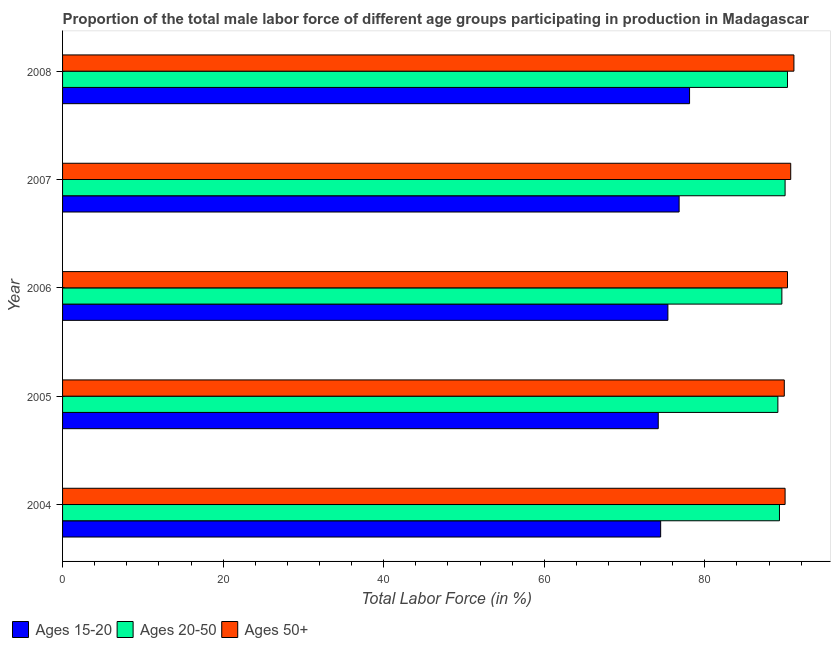How many different coloured bars are there?
Offer a terse response. 3. Are the number of bars on each tick of the Y-axis equal?
Give a very brief answer. Yes. How many bars are there on the 5th tick from the top?
Your answer should be very brief. 3. How many bars are there on the 3rd tick from the bottom?
Provide a short and direct response. 3. In how many cases, is the number of bars for a given year not equal to the number of legend labels?
Give a very brief answer. 0. What is the percentage of male labor force within the age group 20-50 in 2005?
Ensure brevity in your answer.  89.1. Across all years, what is the maximum percentage of male labor force within the age group 20-50?
Your response must be concise. 90.3. Across all years, what is the minimum percentage of male labor force within the age group 20-50?
Offer a terse response. 89.1. In which year was the percentage of male labor force within the age group 20-50 minimum?
Provide a succinct answer. 2005. What is the total percentage of male labor force above age 50 in the graph?
Make the answer very short. 452. What is the difference between the percentage of male labor force within the age group 15-20 in 2004 and that in 2007?
Give a very brief answer. -2.3. What is the difference between the percentage of male labor force within the age group 15-20 in 2006 and the percentage of male labor force within the age group 20-50 in 2008?
Keep it short and to the point. -14.9. What is the average percentage of male labor force within the age group 15-20 per year?
Offer a very short reply. 75.8. In how many years, is the percentage of male labor force above age 50 greater than 84 %?
Offer a terse response. 5. Is the difference between the percentage of male labor force above age 50 in 2004 and 2008 greater than the difference between the percentage of male labor force within the age group 15-20 in 2004 and 2008?
Offer a terse response. Yes. In how many years, is the percentage of male labor force within the age group 20-50 greater than the average percentage of male labor force within the age group 20-50 taken over all years?
Make the answer very short. 2. What does the 1st bar from the top in 2007 represents?
Your answer should be compact. Ages 50+. What does the 2nd bar from the bottom in 2007 represents?
Your answer should be compact. Ages 20-50. Are all the bars in the graph horizontal?
Offer a very short reply. Yes. How many years are there in the graph?
Provide a succinct answer. 5. Are the values on the major ticks of X-axis written in scientific E-notation?
Your response must be concise. No. Does the graph contain any zero values?
Provide a short and direct response. No. How are the legend labels stacked?
Offer a very short reply. Horizontal. What is the title of the graph?
Provide a succinct answer. Proportion of the total male labor force of different age groups participating in production in Madagascar. What is the label or title of the X-axis?
Keep it short and to the point. Total Labor Force (in %). What is the label or title of the Y-axis?
Keep it short and to the point. Year. What is the Total Labor Force (in %) in Ages 15-20 in 2004?
Your answer should be very brief. 74.5. What is the Total Labor Force (in %) in Ages 20-50 in 2004?
Provide a succinct answer. 89.3. What is the Total Labor Force (in %) of Ages 15-20 in 2005?
Make the answer very short. 74.2. What is the Total Labor Force (in %) of Ages 20-50 in 2005?
Provide a succinct answer. 89.1. What is the Total Labor Force (in %) in Ages 50+ in 2005?
Ensure brevity in your answer.  89.9. What is the Total Labor Force (in %) in Ages 15-20 in 2006?
Offer a terse response. 75.4. What is the Total Labor Force (in %) of Ages 20-50 in 2006?
Provide a short and direct response. 89.6. What is the Total Labor Force (in %) of Ages 50+ in 2006?
Your answer should be very brief. 90.3. What is the Total Labor Force (in %) of Ages 15-20 in 2007?
Give a very brief answer. 76.8. What is the Total Labor Force (in %) of Ages 50+ in 2007?
Give a very brief answer. 90.7. What is the Total Labor Force (in %) in Ages 15-20 in 2008?
Make the answer very short. 78.1. What is the Total Labor Force (in %) of Ages 20-50 in 2008?
Your response must be concise. 90.3. What is the Total Labor Force (in %) in Ages 50+ in 2008?
Ensure brevity in your answer.  91.1. Across all years, what is the maximum Total Labor Force (in %) of Ages 15-20?
Your answer should be compact. 78.1. Across all years, what is the maximum Total Labor Force (in %) of Ages 20-50?
Ensure brevity in your answer.  90.3. Across all years, what is the maximum Total Labor Force (in %) in Ages 50+?
Keep it short and to the point. 91.1. Across all years, what is the minimum Total Labor Force (in %) of Ages 15-20?
Ensure brevity in your answer.  74.2. Across all years, what is the minimum Total Labor Force (in %) of Ages 20-50?
Give a very brief answer. 89.1. Across all years, what is the minimum Total Labor Force (in %) in Ages 50+?
Offer a very short reply. 89.9. What is the total Total Labor Force (in %) of Ages 15-20 in the graph?
Offer a very short reply. 379. What is the total Total Labor Force (in %) in Ages 20-50 in the graph?
Provide a short and direct response. 448.3. What is the total Total Labor Force (in %) of Ages 50+ in the graph?
Your answer should be very brief. 452. What is the difference between the Total Labor Force (in %) of Ages 15-20 in 2004 and that in 2005?
Ensure brevity in your answer.  0.3. What is the difference between the Total Labor Force (in %) of Ages 50+ in 2004 and that in 2005?
Your response must be concise. 0.1. What is the difference between the Total Labor Force (in %) of Ages 20-50 in 2004 and that in 2006?
Your answer should be very brief. -0.3. What is the difference between the Total Labor Force (in %) of Ages 50+ in 2004 and that in 2006?
Your answer should be very brief. -0.3. What is the difference between the Total Labor Force (in %) of Ages 15-20 in 2004 and that in 2007?
Your answer should be very brief. -2.3. What is the difference between the Total Labor Force (in %) of Ages 20-50 in 2004 and that in 2007?
Make the answer very short. -0.7. What is the difference between the Total Labor Force (in %) in Ages 50+ in 2004 and that in 2007?
Your answer should be compact. -0.7. What is the difference between the Total Labor Force (in %) in Ages 15-20 in 2004 and that in 2008?
Provide a succinct answer. -3.6. What is the difference between the Total Labor Force (in %) in Ages 50+ in 2004 and that in 2008?
Offer a very short reply. -1.1. What is the difference between the Total Labor Force (in %) in Ages 20-50 in 2005 and that in 2006?
Make the answer very short. -0.5. What is the difference between the Total Labor Force (in %) of Ages 15-20 in 2005 and that in 2007?
Keep it short and to the point. -2.6. What is the difference between the Total Labor Force (in %) of Ages 50+ in 2005 and that in 2007?
Offer a very short reply. -0.8. What is the difference between the Total Labor Force (in %) of Ages 15-20 in 2006 and that in 2008?
Make the answer very short. -2.7. What is the difference between the Total Labor Force (in %) of Ages 20-50 in 2006 and that in 2008?
Your answer should be very brief. -0.7. What is the difference between the Total Labor Force (in %) of Ages 50+ in 2006 and that in 2008?
Your answer should be compact. -0.8. What is the difference between the Total Labor Force (in %) in Ages 20-50 in 2007 and that in 2008?
Keep it short and to the point. -0.3. What is the difference between the Total Labor Force (in %) of Ages 15-20 in 2004 and the Total Labor Force (in %) of Ages 20-50 in 2005?
Offer a terse response. -14.6. What is the difference between the Total Labor Force (in %) in Ages 15-20 in 2004 and the Total Labor Force (in %) in Ages 50+ in 2005?
Provide a short and direct response. -15.4. What is the difference between the Total Labor Force (in %) of Ages 20-50 in 2004 and the Total Labor Force (in %) of Ages 50+ in 2005?
Keep it short and to the point. -0.6. What is the difference between the Total Labor Force (in %) of Ages 15-20 in 2004 and the Total Labor Force (in %) of Ages 20-50 in 2006?
Your answer should be compact. -15.1. What is the difference between the Total Labor Force (in %) of Ages 15-20 in 2004 and the Total Labor Force (in %) of Ages 50+ in 2006?
Offer a terse response. -15.8. What is the difference between the Total Labor Force (in %) of Ages 15-20 in 2004 and the Total Labor Force (in %) of Ages 20-50 in 2007?
Your answer should be compact. -15.5. What is the difference between the Total Labor Force (in %) of Ages 15-20 in 2004 and the Total Labor Force (in %) of Ages 50+ in 2007?
Your answer should be compact. -16.2. What is the difference between the Total Labor Force (in %) of Ages 20-50 in 2004 and the Total Labor Force (in %) of Ages 50+ in 2007?
Provide a short and direct response. -1.4. What is the difference between the Total Labor Force (in %) in Ages 15-20 in 2004 and the Total Labor Force (in %) in Ages 20-50 in 2008?
Your answer should be compact. -15.8. What is the difference between the Total Labor Force (in %) of Ages 15-20 in 2004 and the Total Labor Force (in %) of Ages 50+ in 2008?
Ensure brevity in your answer.  -16.6. What is the difference between the Total Labor Force (in %) of Ages 15-20 in 2005 and the Total Labor Force (in %) of Ages 20-50 in 2006?
Your answer should be compact. -15.4. What is the difference between the Total Labor Force (in %) in Ages 15-20 in 2005 and the Total Labor Force (in %) in Ages 50+ in 2006?
Make the answer very short. -16.1. What is the difference between the Total Labor Force (in %) in Ages 20-50 in 2005 and the Total Labor Force (in %) in Ages 50+ in 2006?
Your answer should be compact. -1.2. What is the difference between the Total Labor Force (in %) of Ages 15-20 in 2005 and the Total Labor Force (in %) of Ages 20-50 in 2007?
Give a very brief answer. -15.8. What is the difference between the Total Labor Force (in %) of Ages 15-20 in 2005 and the Total Labor Force (in %) of Ages 50+ in 2007?
Provide a succinct answer. -16.5. What is the difference between the Total Labor Force (in %) in Ages 20-50 in 2005 and the Total Labor Force (in %) in Ages 50+ in 2007?
Keep it short and to the point. -1.6. What is the difference between the Total Labor Force (in %) in Ages 15-20 in 2005 and the Total Labor Force (in %) in Ages 20-50 in 2008?
Your answer should be compact. -16.1. What is the difference between the Total Labor Force (in %) in Ages 15-20 in 2005 and the Total Labor Force (in %) in Ages 50+ in 2008?
Offer a terse response. -16.9. What is the difference between the Total Labor Force (in %) in Ages 20-50 in 2005 and the Total Labor Force (in %) in Ages 50+ in 2008?
Provide a succinct answer. -2. What is the difference between the Total Labor Force (in %) of Ages 15-20 in 2006 and the Total Labor Force (in %) of Ages 20-50 in 2007?
Make the answer very short. -14.6. What is the difference between the Total Labor Force (in %) in Ages 15-20 in 2006 and the Total Labor Force (in %) in Ages 50+ in 2007?
Provide a short and direct response. -15.3. What is the difference between the Total Labor Force (in %) in Ages 20-50 in 2006 and the Total Labor Force (in %) in Ages 50+ in 2007?
Offer a terse response. -1.1. What is the difference between the Total Labor Force (in %) in Ages 15-20 in 2006 and the Total Labor Force (in %) in Ages 20-50 in 2008?
Ensure brevity in your answer.  -14.9. What is the difference between the Total Labor Force (in %) in Ages 15-20 in 2006 and the Total Labor Force (in %) in Ages 50+ in 2008?
Your response must be concise. -15.7. What is the difference between the Total Labor Force (in %) in Ages 15-20 in 2007 and the Total Labor Force (in %) in Ages 20-50 in 2008?
Your response must be concise. -13.5. What is the difference between the Total Labor Force (in %) of Ages 15-20 in 2007 and the Total Labor Force (in %) of Ages 50+ in 2008?
Provide a succinct answer. -14.3. What is the average Total Labor Force (in %) of Ages 15-20 per year?
Provide a short and direct response. 75.8. What is the average Total Labor Force (in %) in Ages 20-50 per year?
Provide a short and direct response. 89.66. What is the average Total Labor Force (in %) in Ages 50+ per year?
Give a very brief answer. 90.4. In the year 2004, what is the difference between the Total Labor Force (in %) in Ages 15-20 and Total Labor Force (in %) in Ages 20-50?
Make the answer very short. -14.8. In the year 2004, what is the difference between the Total Labor Force (in %) of Ages 15-20 and Total Labor Force (in %) of Ages 50+?
Keep it short and to the point. -15.5. In the year 2005, what is the difference between the Total Labor Force (in %) of Ages 15-20 and Total Labor Force (in %) of Ages 20-50?
Your answer should be very brief. -14.9. In the year 2005, what is the difference between the Total Labor Force (in %) of Ages 15-20 and Total Labor Force (in %) of Ages 50+?
Provide a short and direct response. -15.7. In the year 2006, what is the difference between the Total Labor Force (in %) of Ages 15-20 and Total Labor Force (in %) of Ages 50+?
Offer a very short reply. -14.9. In the year 2008, what is the difference between the Total Labor Force (in %) of Ages 15-20 and Total Labor Force (in %) of Ages 20-50?
Keep it short and to the point. -12.2. What is the ratio of the Total Labor Force (in %) in Ages 50+ in 2004 to that in 2005?
Your answer should be very brief. 1. What is the ratio of the Total Labor Force (in %) in Ages 15-20 in 2004 to that in 2007?
Give a very brief answer. 0.97. What is the ratio of the Total Labor Force (in %) in Ages 20-50 in 2004 to that in 2007?
Your answer should be very brief. 0.99. What is the ratio of the Total Labor Force (in %) in Ages 15-20 in 2004 to that in 2008?
Give a very brief answer. 0.95. What is the ratio of the Total Labor Force (in %) in Ages 20-50 in 2004 to that in 2008?
Ensure brevity in your answer.  0.99. What is the ratio of the Total Labor Force (in %) in Ages 50+ in 2004 to that in 2008?
Make the answer very short. 0.99. What is the ratio of the Total Labor Force (in %) of Ages 15-20 in 2005 to that in 2006?
Ensure brevity in your answer.  0.98. What is the ratio of the Total Labor Force (in %) in Ages 20-50 in 2005 to that in 2006?
Offer a terse response. 0.99. What is the ratio of the Total Labor Force (in %) of Ages 15-20 in 2005 to that in 2007?
Keep it short and to the point. 0.97. What is the ratio of the Total Labor Force (in %) in Ages 15-20 in 2005 to that in 2008?
Make the answer very short. 0.95. What is the ratio of the Total Labor Force (in %) of Ages 20-50 in 2005 to that in 2008?
Keep it short and to the point. 0.99. What is the ratio of the Total Labor Force (in %) in Ages 50+ in 2005 to that in 2008?
Offer a very short reply. 0.99. What is the ratio of the Total Labor Force (in %) in Ages 15-20 in 2006 to that in 2007?
Offer a very short reply. 0.98. What is the ratio of the Total Labor Force (in %) of Ages 15-20 in 2006 to that in 2008?
Your response must be concise. 0.97. What is the ratio of the Total Labor Force (in %) in Ages 20-50 in 2006 to that in 2008?
Give a very brief answer. 0.99. What is the ratio of the Total Labor Force (in %) in Ages 15-20 in 2007 to that in 2008?
Provide a succinct answer. 0.98. What is the difference between the highest and the second highest Total Labor Force (in %) of Ages 15-20?
Make the answer very short. 1.3. What is the difference between the highest and the second highest Total Labor Force (in %) of Ages 20-50?
Make the answer very short. 0.3. What is the difference between the highest and the lowest Total Labor Force (in %) in Ages 15-20?
Your response must be concise. 3.9. What is the difference between the highest and the lowest Total Labor Force (in %) in Ages 20-50?
Offer a terse response. 1.2. What is the difference between the highest and the lowest Total Labor Force (in %) in Ages 50+?
Give a very brief answer. 1.2. 